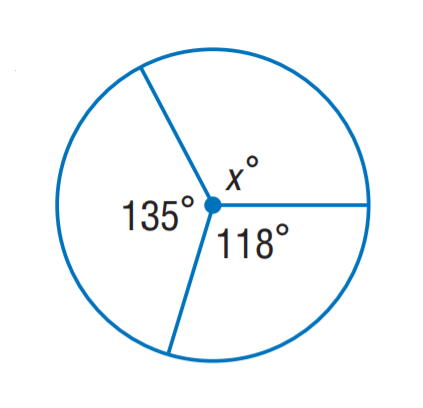Answer the mathemtical geometry problem and directly provide the correct option letter.
Question: Find x.
Choices: A: 107 B: 117 C: 118 D: 135 A 